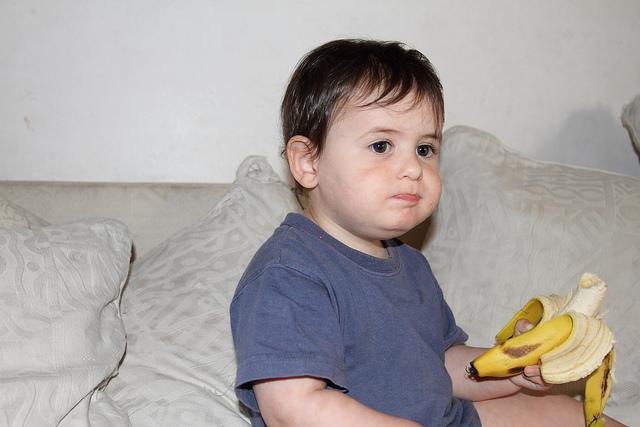What color is the boy's neck?
Give a very brief answer. White. Does the child have dark eyes?
Answer briefly. Yes. Is the child clean?
Quick response, please. Yes. Where is the baby sitting?
Concise answer only. Couch. What is in this person's mouth?
Keep it brief. Banana. How many children are eating?
Quick response, please. 1. Is this a male?
Concise answer only. Yes. What is the baby wearing?
Concise answer only. Shirt. What is the baby holding?
Give a very brief answer. Banana. What is the child sitting in?
Write a very short answer. Couch. Is this healthy?
Give a very brief answer. Yes. What type of shirt is the child wearing?
Concise answer only. T-shirt. Does the child appear to be relaxed?
Write a very short answer. Yes. Is this child enjoying his banana?
Short answer required. No. What is this baby eating?
Short answer required. Banana. Is the child wearing a bib?
Answer briefly. No. Is the baby happy?
Write a very short answer. No. What is the little boy eating?
Quick response, please. Banana. What colors is the comforter?
Keep it brief. Gray. 